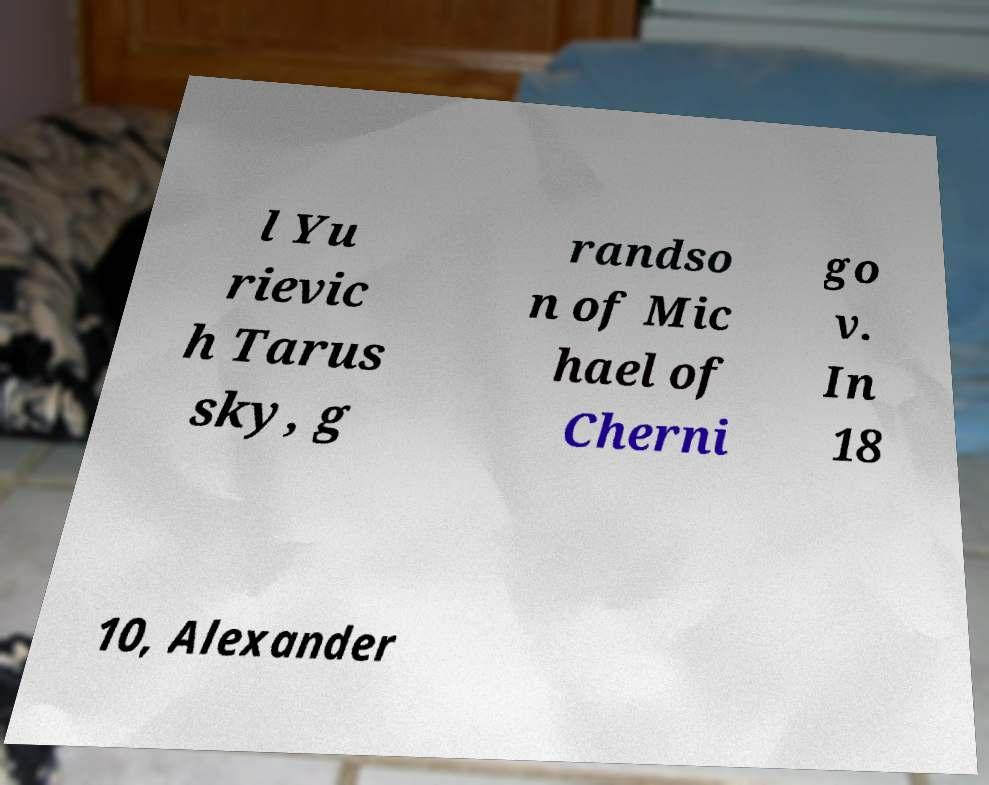I need the written content from this picture converted into text. Can you do that? l Yu rievic h Tarus sky, g randso n of Mic hael of Cherni go v. In 18 10, Alexander 